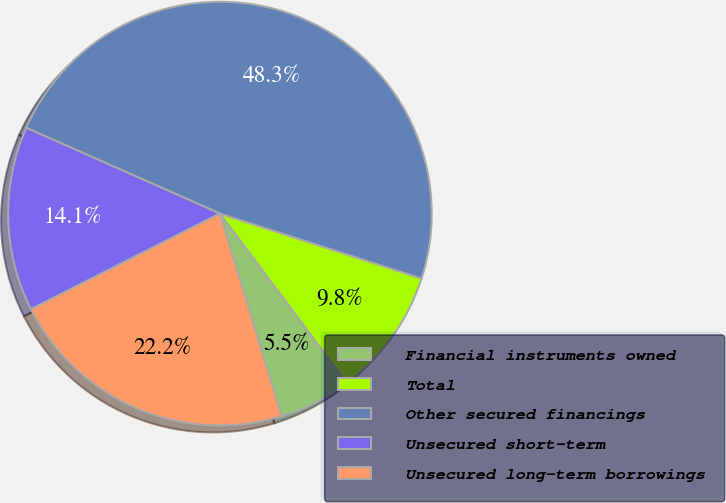<chart> <loc_0><loc_0><loc_500><loc_500><pie_chart><fcel>Financial instruments owned<fcel>Total<fcel>Other secured financings<fcel>Unsecured short-term<fcel>Unsecured long-term borrowings<nl><fcel>5.53%<fcel>9.81%<fcel>48.32%<fcel>14.09%<fcel>22.24%<nl></chart> 